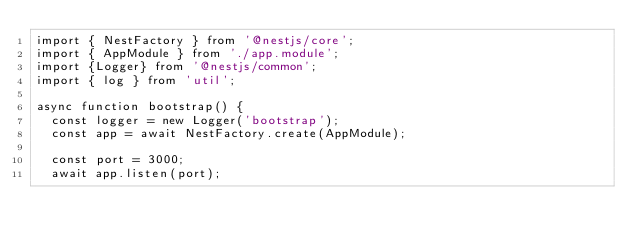<code> <loc_0><loc_0><loc_500><loc_500><_TypeScript_>import { NestFactory } from '@nestjs/core';
import { AppModule } from './app.module';
import {Logger} from '@nestjs/common';
import { log } from 'util';

async function bootstrap() {
  const logger = new Logger('bootstrap');
  const app = await NestFactory.create(AppModule);
  
  const port = 3000;
  await app.listen(port);
</code> 